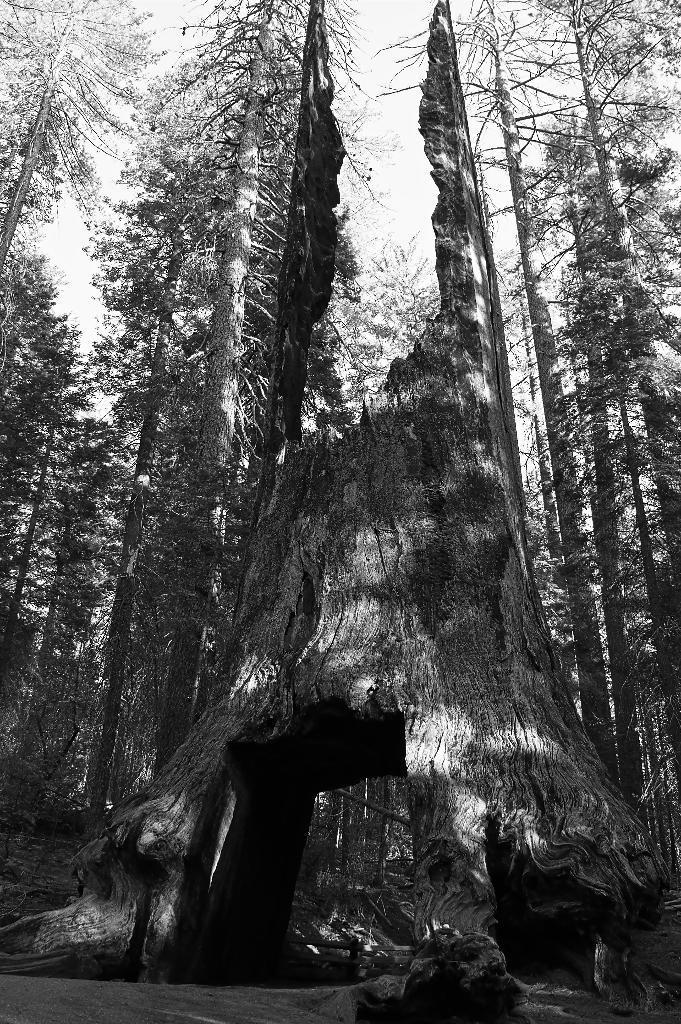How would you summarize this image in a sentence or two? It is a black and white image. In this image in front there is a tree trunk. In the background of the image there are trees and sky. 